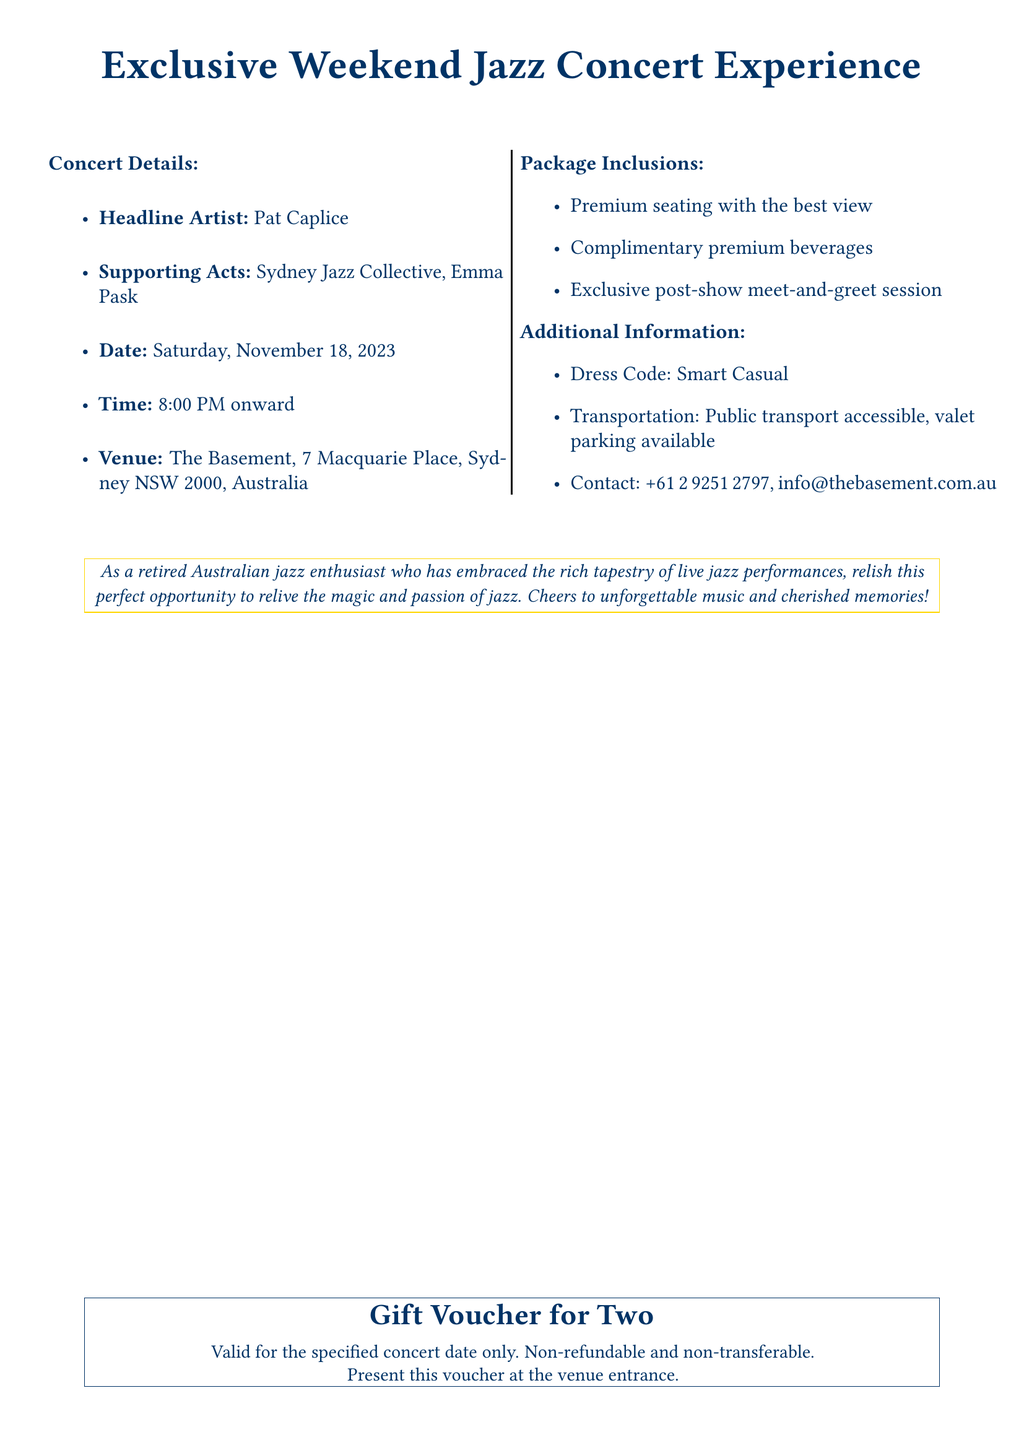What is the date of the concert? The date of the concert is specified in the document, which states Saturday, November 18, 2023.
Answer: Saturday, November 18, 2023 Who is the headline artist? The headline artist is mentioned in the document and is clearly identified as Pat Caplice.
Answer: Pat Caplice What is included in the package? The document lists several inclusions in the package, such as premium seating, complimentary beverages, and a meet-and-greet session.
Answer: Premium seating, complimentary premium beverages, exclusive post-show meet-and-greet session What time does the concert start? The concert start time is provided in the document, stating it begins at 8:00 PM onward.
Answer: 8:00 PM What is the dress code? The dress code is explicitly mentioned in the additional information section of the document, which notes it as smart casual.
Answer: Smart Casual What is the venue address? The address of the venue is detailed within the document, specifying The Basement, 7 Macquarie Place, Sydney NSW 2000, Australia.
Answer: The Basement, 7 Macquarie Place, Sydney NSW 2000, Australia Is the voucher transferable? The document specifies the nature of the voucher under package inclusions, stating it is non-transferable.
Answer: Non-transferable What type of event does this voucher provide access to? The document clarifies that the voucher provides access to a jazz concert experience.
Answer: Jazz concert experience 